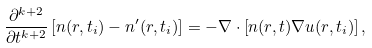<formula> <loc_0><loc_0><loc_500><loc_500>\frac { \partial ^ { k + 2 } } { \partial t ^ { k + 2 } } \left [ n ( r , t _ { i } ) - n ^ { \prime } ( r , t _ { i } ) \right ] = - \nabla \cdot \left [ n ( r , t ) \nabla u ( r , t _ { i } ) \right ] ,</formula> 